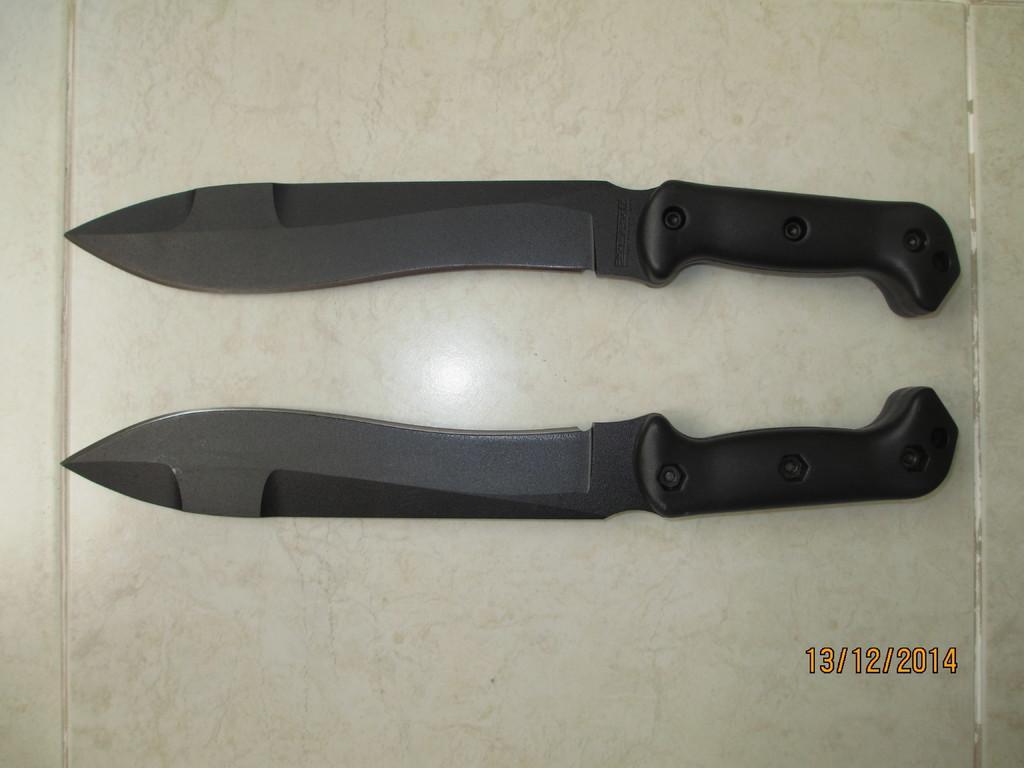Describe this image in one or two sentences. There are two black knives on the table. 